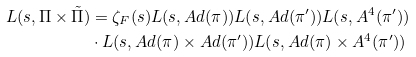Convert formula to latex. <formula><loc_0><loc_0><loc_500><loc_500>L ( s , \Pi \times \tilde { \Pi } ) & = \zeta _ { F } ( s ) L ( s , A d ( \pi ) ) L ( s , A d ( \pi ^ { \prime } ) ) L ( s , A ^ { 4 } ( \pi ^ { \prime } ) ) \\ & \cdot L ( s , A d ( \pi ) \times A d ( \pi ^ { \prime } ) ) L ( s , A d ( \pi ) \times A ^ { 4 } ( \pi ^ { \prime } ) )</formula> 